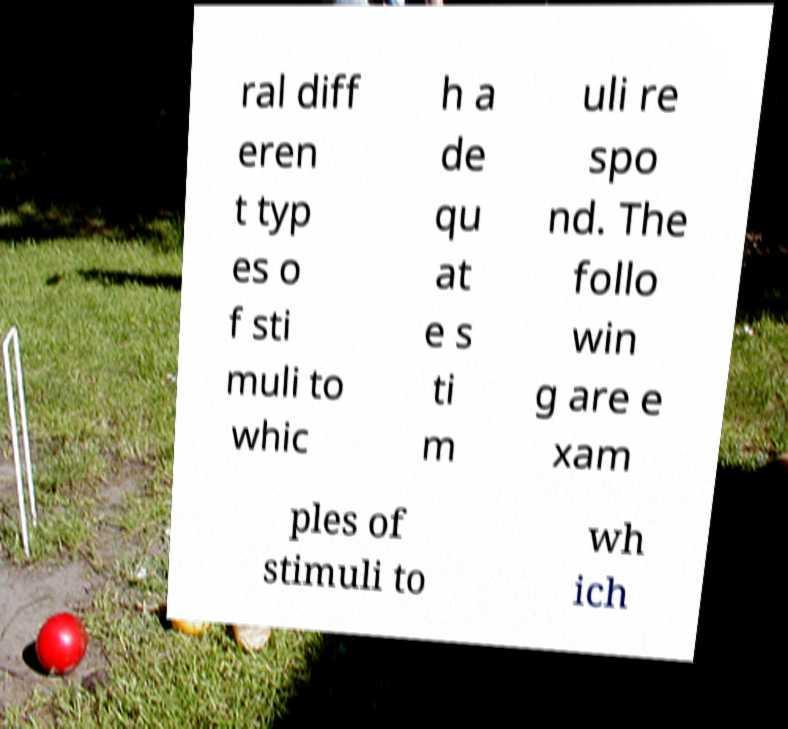Can you accurately transcribe the text from the provided image for me? ral diff eren t typ es o f sti muli to whic h a de qu at e s ti m uli re spo nd. The follo win g are e xam ples of stimuli to wh ich 